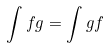<formula> <loc_0><loc_0><loc_500><loc_500>\int f g = \int g f</formula> 